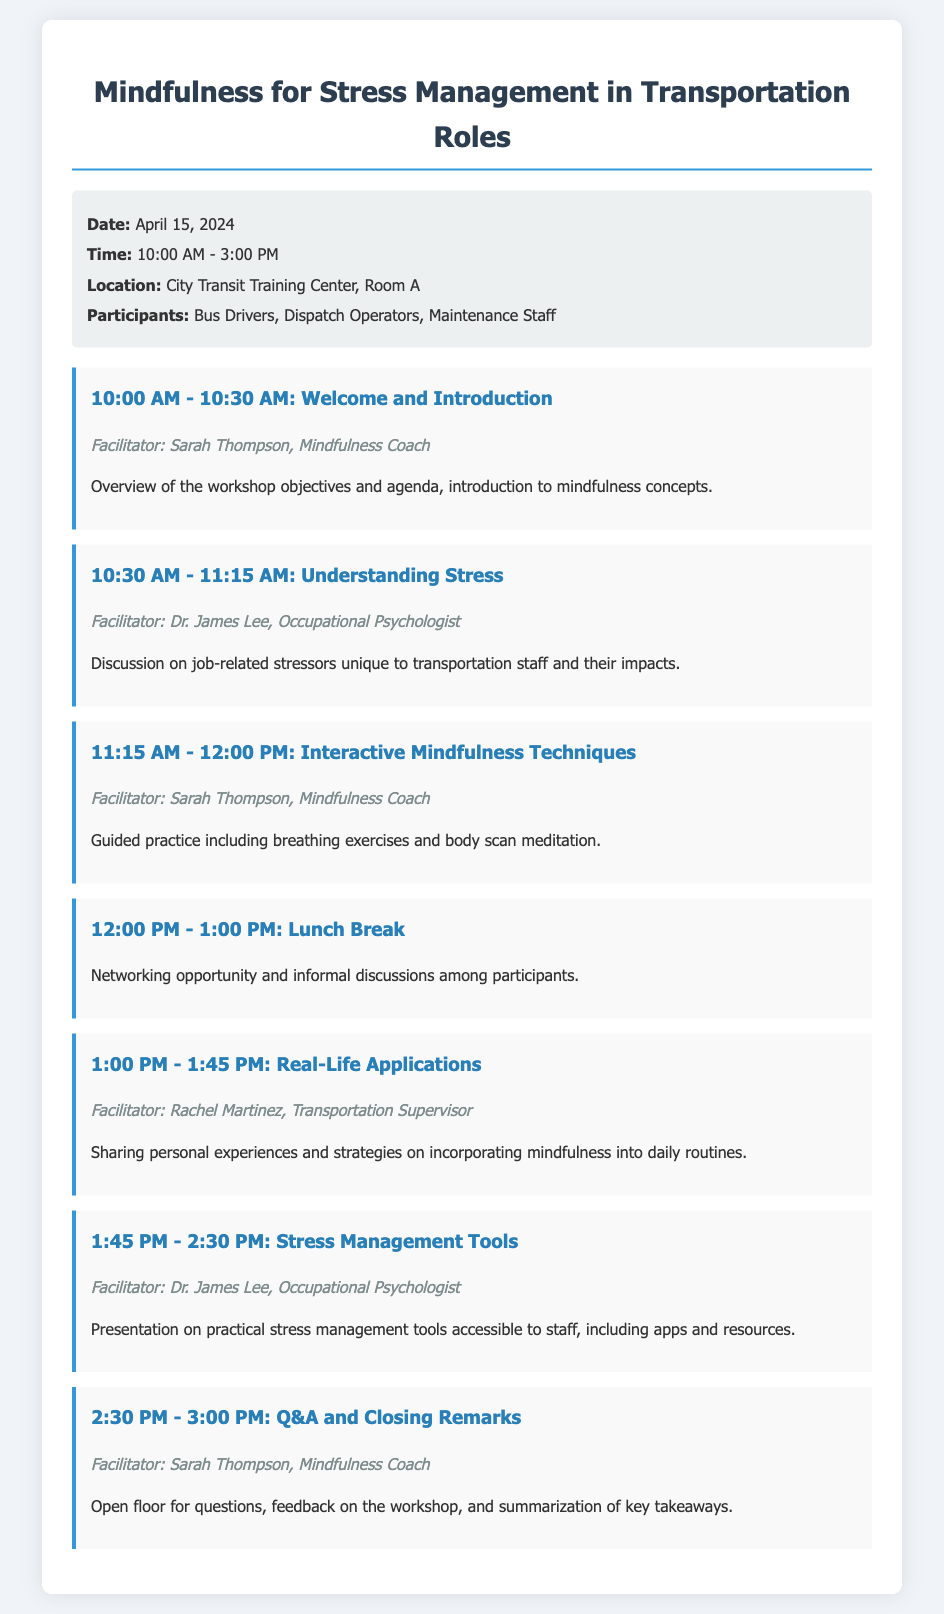What is the date of the workshop? The date of the workshop is listed in the document under the info section.
Answer: April 15, 2024 Who is the facilitator for the "Understanding Stress" session? Each agenda item lists the facilitator for that session.
Answer: Dr. James Lee What time does the lunch break start? The time for the lunch break is clearly indicated in the agenda.
Answer: 12:00 PM How long is the "Real-Life Applications" session? The duration can be found in the agenda where this session is listed.
Answer: 45 minutes What city is the workshop location in? The location section of the document specifies this information.
Answer: City Transit Training Center Which session features breathing exercises? The content of each agenda item specifies what techniques will be practiced.
Answer: Interactive Mindfulness Techniques What is the main focus of the workshop? The title and introductory information clarify the purpose of the workshop.
Answer: Mindfulness for Stress Management How many participants are listed for the workshop? The participants section details who is expected to attend the workshop.
Answer: Bus Drivers, Dispatch Operators, Maintenance Staff What is the total duration of the workshop? The start and end times of the workshop provide this calculation.
Answer: 5 hours 